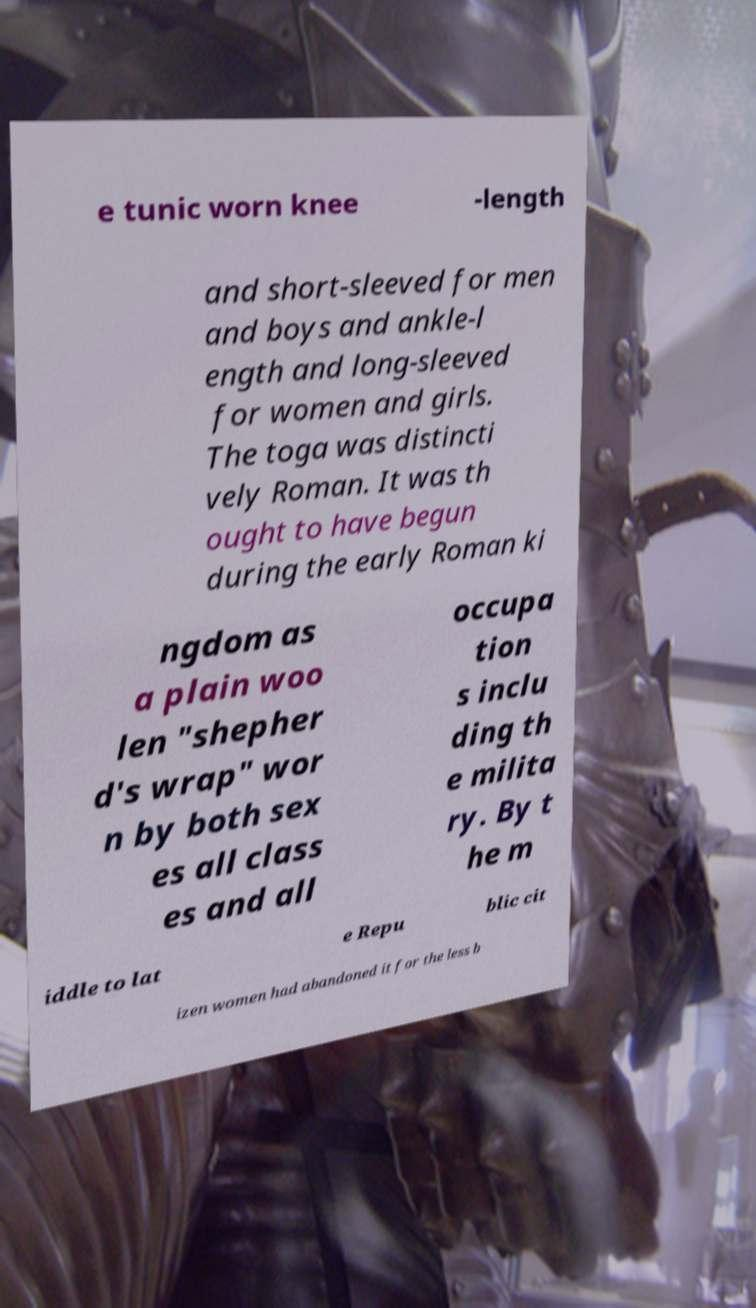Can you accurately transcribe the text from the provided image for me? e tunic worn knee -length and short-sleeved for men and boys and ankle-l ength and long-sleeved for women and girls. The toga was distincti vely Roman. It was th ought to have begun during the early Roman ki ngdom as a plain woo len "shepher d's wrap" wor n by both sex es all class es and all occupa tion s inclu ding th e milita ry. By t he m iddle to lat e Repu blic cit izen women had abandoned it for the less b 